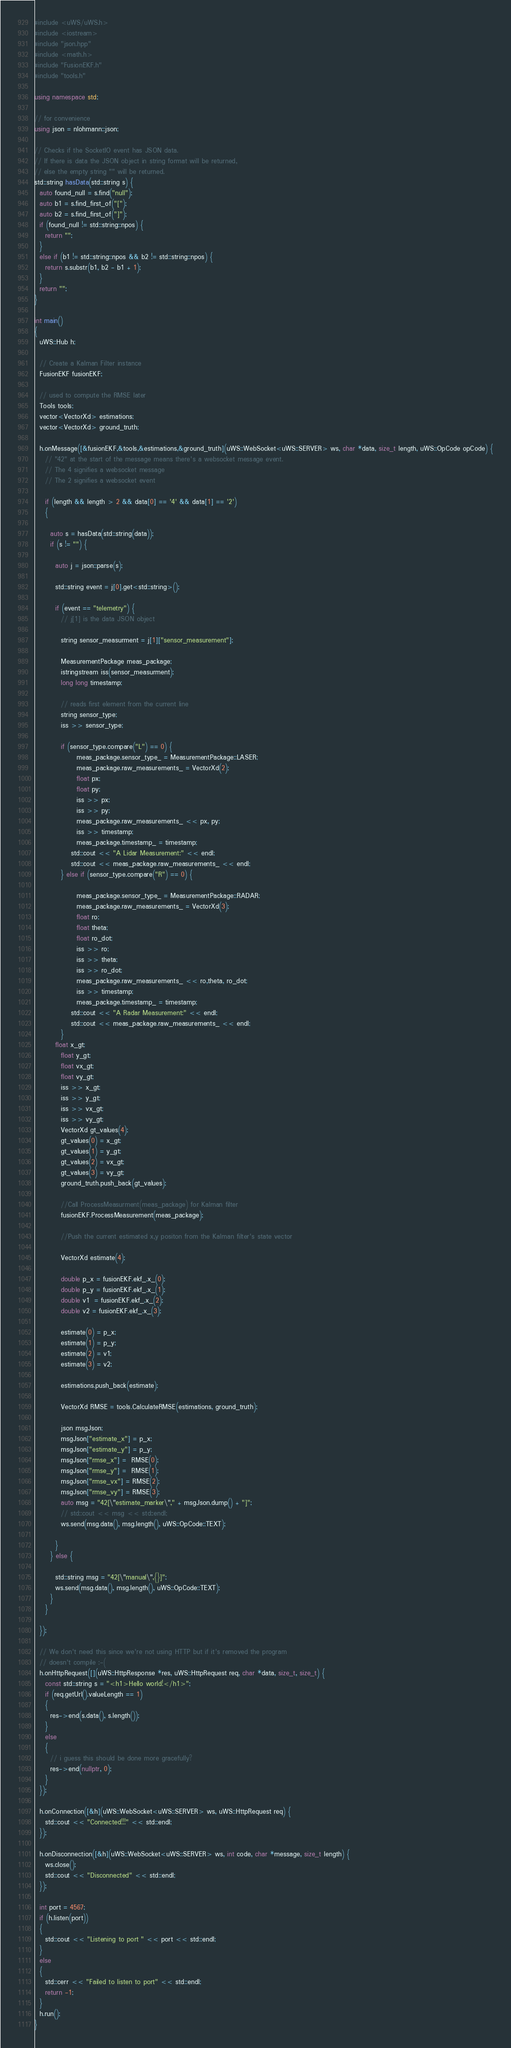Convert code to text. <code><loc_0><loc_0><loc_500><loc_500><_C++_>#include <uWS/uWS.h>
#include <iostream>
#include "json.hpp"
#include <math.h>
#include "FusionEKF.h"
#include "tools.h"

using namespace std;

// for convenience
using json = nlohmann::json;

// Checks if the SocketIO event has JSON data.
// If there is data the JSON object in string format will be returned,
// else the empty string "" will be returned.
std::string hasData(std::string s) {
  auto found_null = s.find("null");
  auto b1 = s.find_first_of("[");
  auto b2 = s.find_first_of("]");
  if (found_null != std::string::npos) {
    return "";
  }
  else if (b1 != std::string::npos && b2 != std::string::npos) {
    return s.substr(b1, b2 - b1 + 1);
  }
  return "";
}

int main()
{
  uWS::Hub h;

  // Create a Kalman Filter instance
  FusionEKF fusionEKF;

  // used to compute the RMSE later
  Tools tools;
  vector<VectorXd> estimations;
  vector<VectorXd> ground_truth;

  h.onMessage([&fusionEKF,&tools,&estimations,&ground_truth](uWS::WebSocket<uWS::SERVER> ws, char *data, size_t length, uWS::OpCode opCode) {
    // "42" at the start of the message means there's a websocket message event.
    // The 4 signifies a websocket message
    // The 2 signifies a websocket event

    if (length && length > 2 && data[0] == '4' && data[1] == '2')
    {

      auto s = hasData(std::string(data));
      if (s != "") {
      	
        auto j = json::parse(s);

        std::string event = j[0].get<std::string>();
        
        if (event == "telemetry") {
          // j[1] is the data JSON object
          
          string sensor_measurment = j[1]["sensor_measurement"];
          
          MeasurementPackage meas_package;
          istringstream iss(sensor_measurment);
    	  long long timestamp;

    	  // reads first element from the current line
    	  string sensor_type;
    	  iss >> sensor_type;

    	  if (sensor_type.compare("L") == 0) {
      	  		meas_package.sensor_type_ = MeasurementPackage::LASER;
          		meas_package.raw_measurements_ = VectorXd(2);
          		float px;
      	  		float py;
          		iss >> px;
          		iss >> py;
          		meas_package.raw_measurements_ << px, py;
          		iss >> timestamp;
          		meas_package.timestamp_ = timestamp;
              std::cout << "A Lidar Measurement:" << endl;
              std::cout << meas_package.raw_measurements_ << endl;
          } else if (sensor_type.compare("R") == 0) {

      	  		meas_package.sensor_type_ = MeasurementPackage::RADAR;
          		meas_package.raw_measurements_ = VectorXd(3);
          		float ro;
      	  		float theta;
      	  		float ro_dot;
          		iss >> ro;
          		iss >> theta;
          		iss >> ro_dot;
          		meas_package.raw_measurements_ << ro,theta, ro_dot;
          		iss >> timestamp;
          		meas_package.timestamp_ = timestamp;
              std::cout << "A Radar Measurement:" << endl;
              std::cout << meas_package.raw_measurements_ << endl;
          }
        float x_gt;
    	  float y_gt;
    	  float vx_gt;
    	  float vy_gt;
    	  iss >> x_gt;
    	  iss >> y_gt;
    	  iss >> vx_gt;
    	  iss >> vy_gt;
    	  VectorXd gt_values(4);
    	  gt_values(0) = x_gt;
    	  gt_values(1) = y_gt; 
    	  gt_values(2) = vx_gt;
    	  gt_values(3) = vy_gt;
    	  ground_truth.push_back(gt_values);
          
          //Call ProcessMeasurment(meas_package) for Kalman filter
    	  fusionEKF.ProcessMeasurement(meas_package);    	  

    	  //Push the current estimated x,y positon from the Kalman filter's state vector

    	  VectorXd estimate(4);

    	  double p_x = fusionEKF.ekf_.x_(0);
    	  double p_y = fusionEKF.ekf_.x_(1);
    	  double v1  = fusionEKF.ekf_.x_(2);
    	  double v2 = fusionEKF.ekf_.x_(3);

    	  estimate(0) = p_x;
    	  estimate(1) = p_y;
    	  estimate(2) = v1;
    	  estimate(3) = v2;
    	  
    	  estimations.push_back(estimate);

    	  VectorXd RMSE = tools.CalculateRMSE(estimations, ground_truth);

          json msgJson;
          msgJson["estimate_x"] = p_x;
          msgJson["estimate_y"] = p_y;
          msgJson["rmse_x"] =  RMSE(0);
          msgJson["rmse_y"] =  RMSE(1);
          msgJson["rmse_vx"] = RMSE(2);
          msgJson["rmse_vy"] = RMSE(3);
          auto msg = "42[\"estimate_marker\"," + msgJson.dump() + "]";
          // std::cout << msg << std::endl;
          ws.send(msg.data(), msg.length(), uWS::OpCode::TEXT);
	  
        }
      } else {
        
        std::string msg = "42[\"manual\",{}]";
        ws.send(msg.data(), msg.length(), uWS::OpCode::TEXT);
      }
    }

  });

  // We don't need this since we're not using HTTP but if it's removed the program
  // doesn't compile :-(
  h.onHttpRequest([](uWS::HttpResponse *res, uWS::HttpRequest req, char *data, size_t, size_t) {
    const std::string s = "<h1>Hello world!</h1>";
    if (req.getUrl().valueLength == 1)
    {
      res->end(s.data(), s.length());
    }
    else
    {
      // i guess this should be done more gracefully?
      res->end(nullptr, 0);
    }
  });

  h.onConnection([&h](uWS::WebSocket<uWS::SERVER> ws, uWS::HttpRequest req) {
    std::cout << "Connected!!!" << std::endl;
  });

  h.onDisconnection([&h](uWS::WebSocket<uWS::SERVER> ws, int code, char *message, size_t length) {
    ws.close();
    std::cout << "Disconnected" << std::endl;
  });

  int port = 4567;
  if (h.listen(port))
  {
    std::cout << "Listening to port " << port << std::endl;
  }
  else
  {
    std::cerr << "Failed to listen to port" << std::endl;
    return -1;
  }
  h.run();
}
</code> 